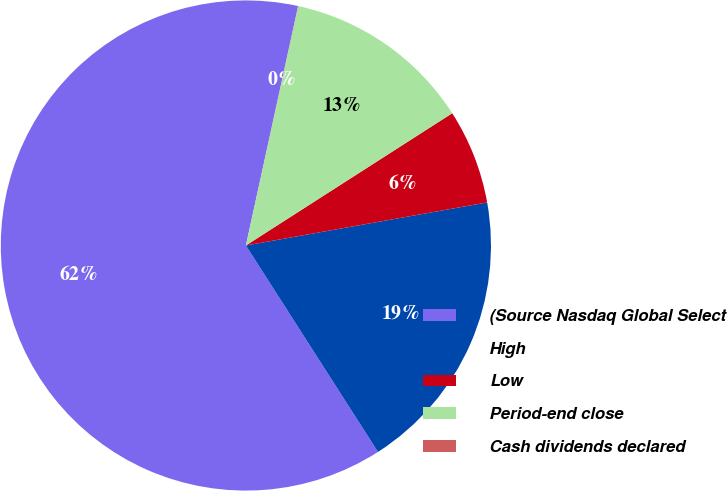<chart> <loc_0><loc_0><loc_500><loc_500><pie_chart><fcel>(Source Nasdaq Global Select<fcel>High<fcel>Low<fcel>Period-end close<fcel>Cash dividends declared<nl><fcel>62.47%<fcel>18.75%<fcel>6.26%<fcel>12.5%<fcel>0.01%<nl></chart> 